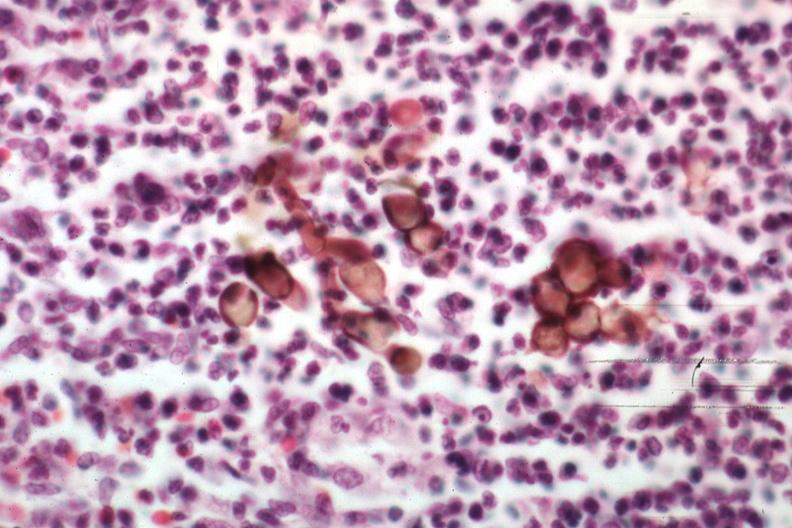s chromoblastomycosis present?
Answer the question using a single word or phrase. Yes 